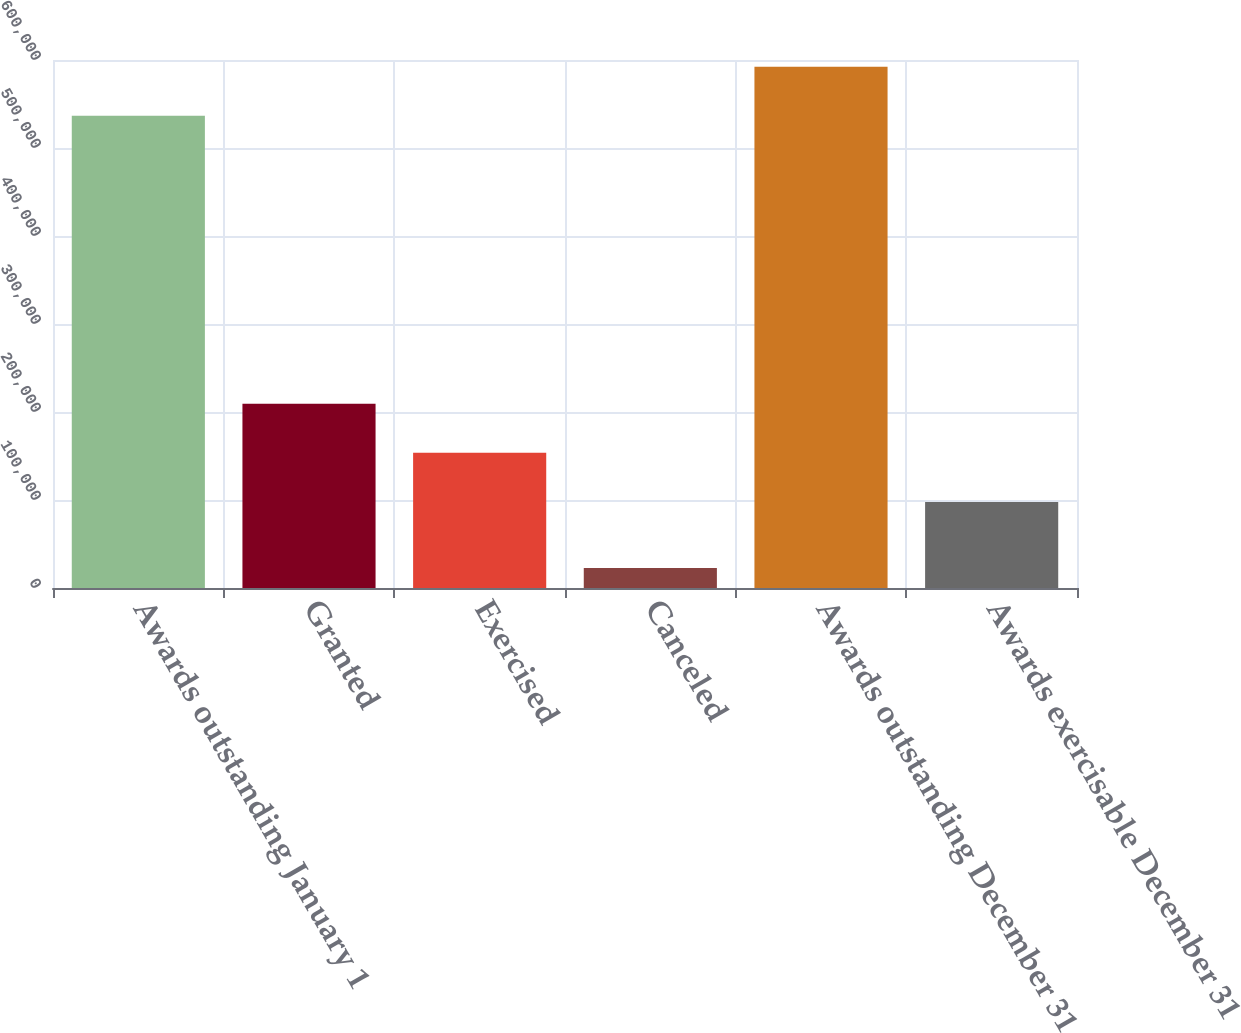<chart> <loc_0><loc_0><loc_500><loc_500><bar_chart><fcel>Awards outstanding January 1<fcel>Granted<fcel>Exercised<fcel>Canceled<fcel>Awards outstanding December 31<fcel>Awards exercisable December 31<nl><fcel>536572<fcel>209473<fcel>153578<fcel>22750<fcel>592466<fcel>97684<nl></chart> 